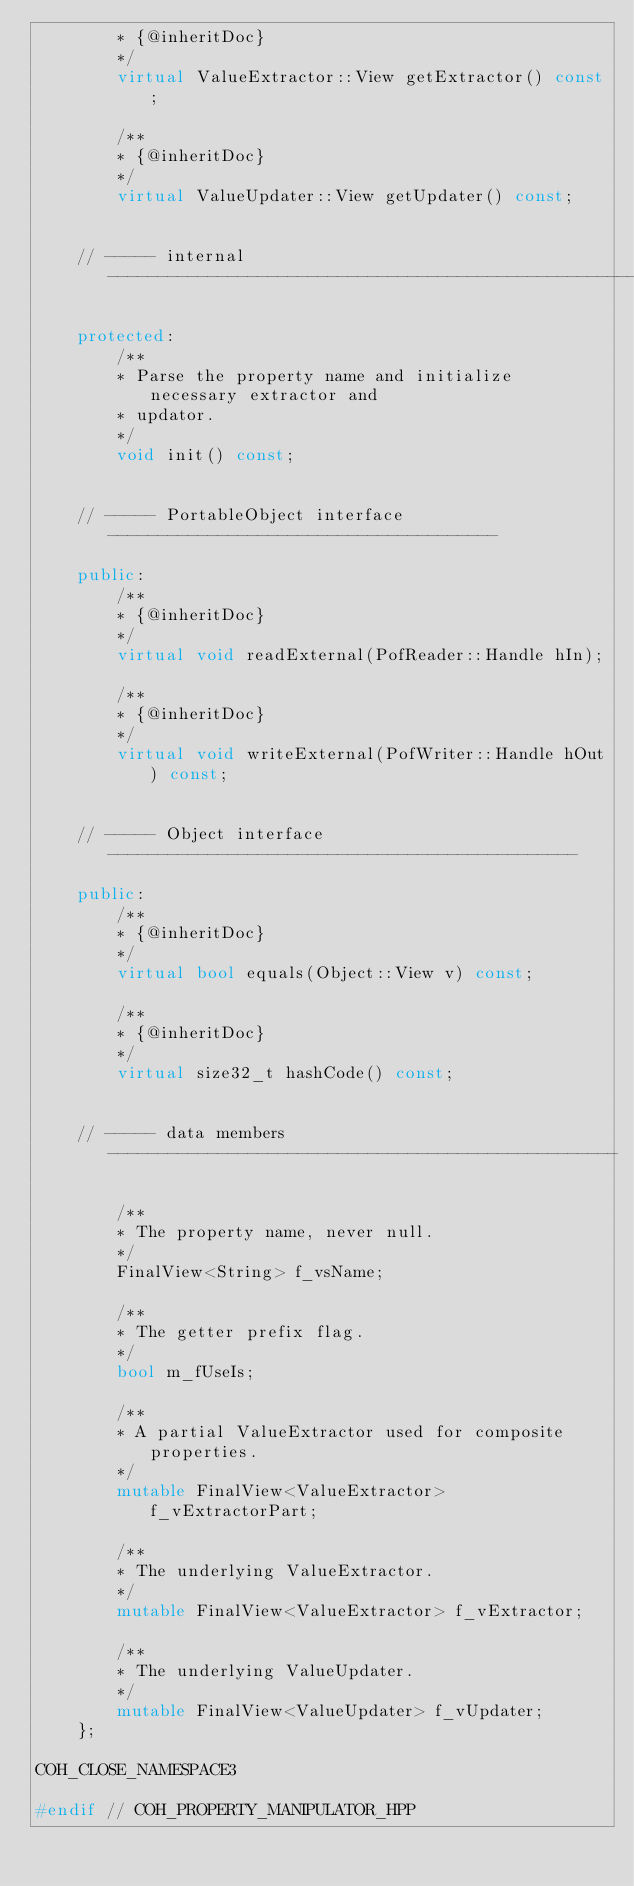Convert code to text. <code><loc_0><loc_0><loc_500><loc_500><_C++_>        * {@inheritDoc}
        */
        virtual ValueExtractor::View getExtractor() const;

        /**
        * {@inheritDoc}
        */
        virtual ValueUpdater::View getUpdater() const;


    // ----- internal -------------------------------------------------------

    protected:
        /**
        * Parse the property name and initialize necessary extractor and
        * updator.
        */
        void init() const;


    // ----- PortableObject interface ---------------------------------------

    public:
        /**
        * {@inheritDoc}
        */
        virtual void readExternal(PofReader::Handle hIn);

        /**
        * {@inheritDoc}
        */
        virtual void writeExternal(PofWriter::Handle hOut) const;


    // ----- Object interface -----------------------------------------------

    public:
        /**
        * {@inheritDoc}
        */
        virtual bool equals(Object::View v) const;

        /**
        * {@inheritDoc}
        */
        virtual size32_t hashCode() const;


    // ----- data members ---------------------------------------------------

        /**
        * The property name, never null.
        */
        FinalView<String> f_vsName;

        /**
        * The getter prefix flag.
        */
        bool m_fUseIs;

        /**
        * A partial ValueExtractor used for composite properties.
        */
        mutable FinalView<ValueExtractor> f_vExtractorPart;

        /**
        * The underlying ValueExtractor.
        */
        mutable FinalView<ValueExtractor> f_vExtractor;

        /**
        * The underlying ValueUpdater.
        */
        mutable FinalView<ValueUpdater> f_vUpdater;
    };

COH_CLOSE_NAMESPACE3

#endif // COH_PROPERTY_MANIPULATOR_HPP
</code> 